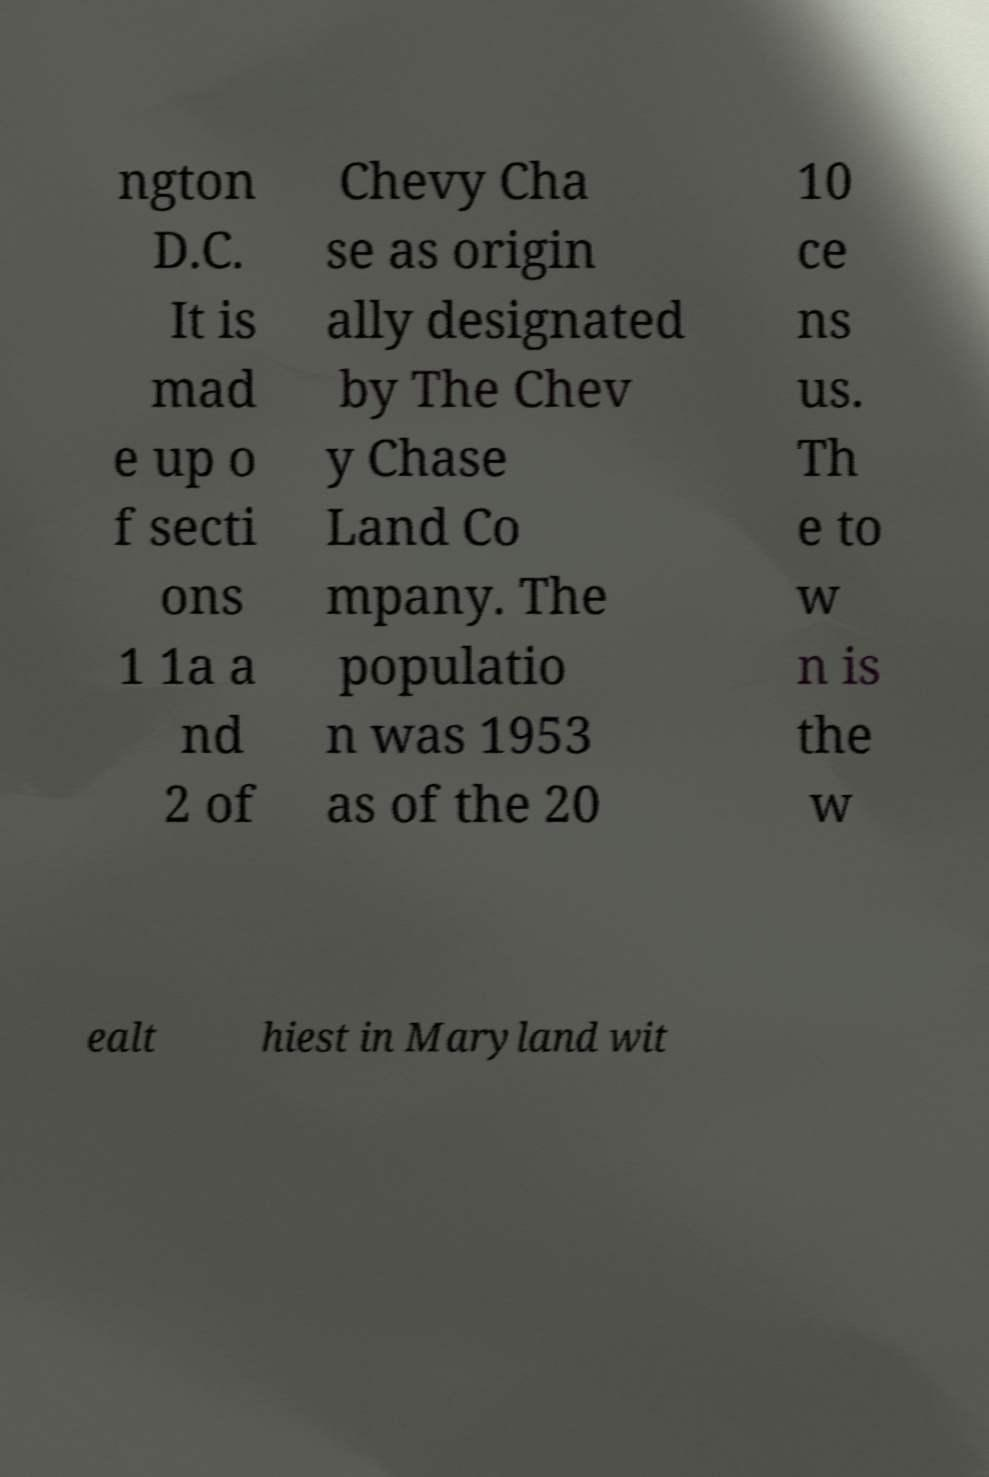Please identify and transcribe the text found in this image. ngton D.C. It is mad e up o f secti ons 1 1a a nd 2 of Chevy Cha se as origin ally designated by The Chev y Chase Land Co mpany. The populatio n was 1953 as of the 20 10 ce ns us. Th e to w n is the w ealt hiest in Maryland wit 